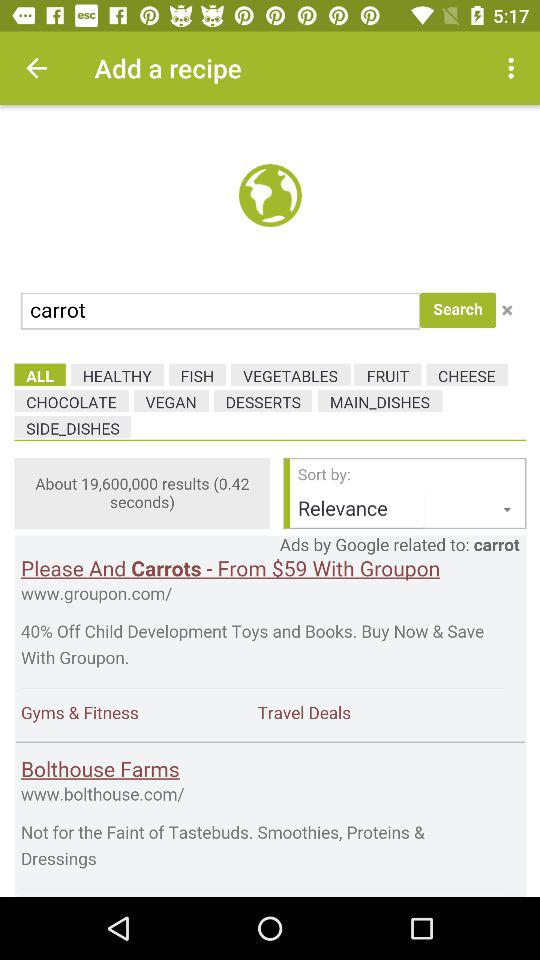What is the cost of carrots on Groupon? The cost of carrots on Groupon is $59. 